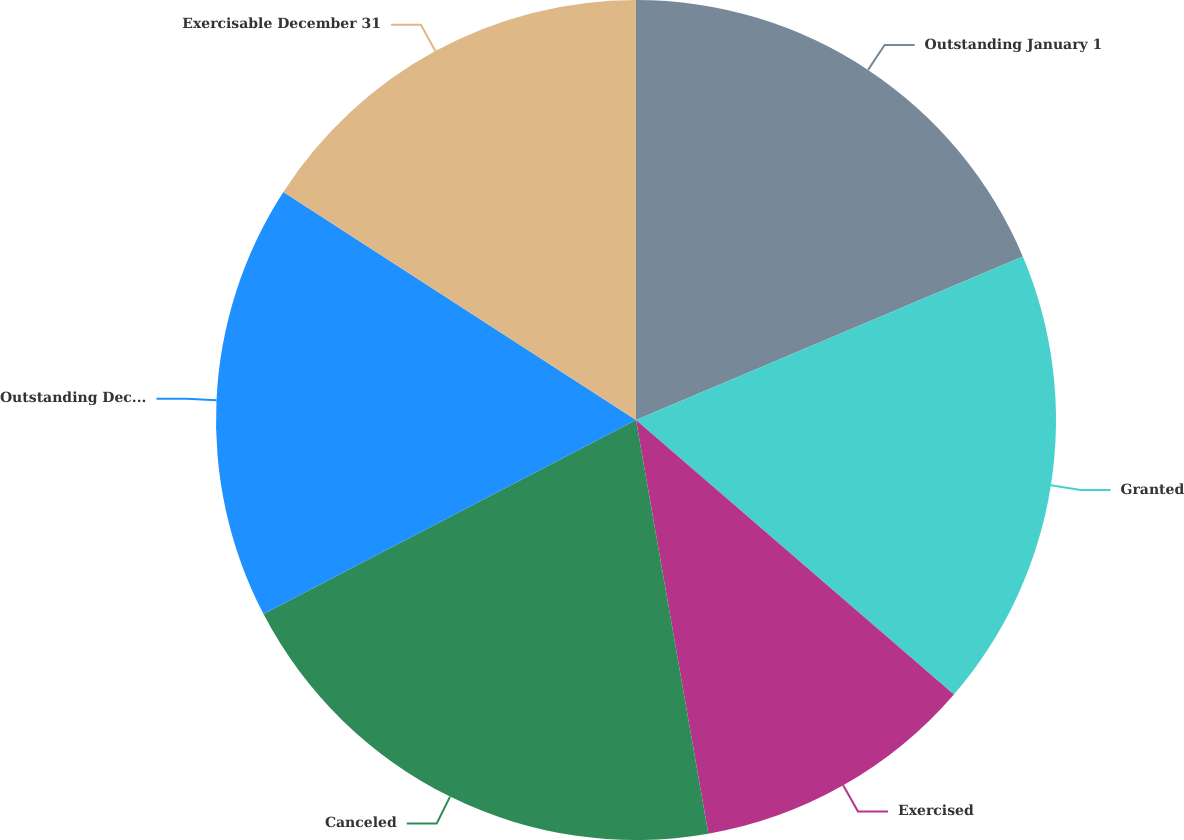Convert chart to OTSL. <chart><loc_0><loc_0><loc_500><loc_500><pie_chart><fcel>Outstanding January 1<fcel>Granted<fcel>Exercised<fcel>Canceled<fcel>Outstanding December 31<fcel>Exercisable December 31<nl><fcel>18.63%<fcel>17.7%<fcel>10.91%<fcel>20.11%<fcel>16.78%<fcel>15.86%<nl></chart> 